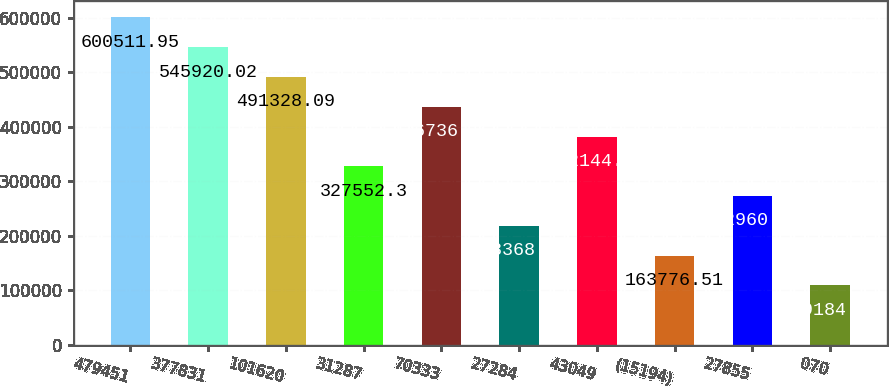<chart> <loc_0><loc_0><loc_500><loc_500><bar_chart><fcel>479451<fcel>377831<fcel>101620<fcel>31287<fcel>70333<fcel>27284<fcel>43049<fcel>(15194)<fcel>27855<fcel>070<nl><fcel>600512<fcel>545920<fcel>491328<fcel>327552<fcel>436736<fcel>218368<fcel>382144<fcel>163777<fcel>272960<fcel>109185<nl></chart> 